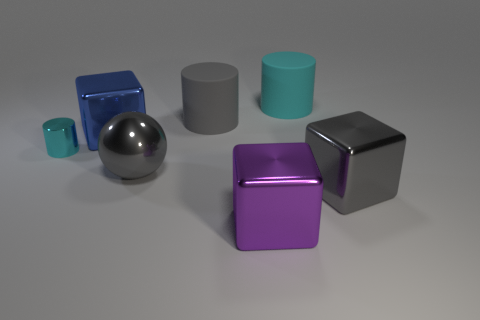There is a big gray cylinder; are there any big rubber things to the right of it?
Keep it short and to the point. Yes. What is the size of the metal block that is the same color as the large ball?
Offer a very short reply. Large. Is there a big purple thing that has the same material as the big ball?
Provide a short and direct response. Yes. The tiny metallic cylinder has what color?
Provide a succinct answer. Cyan. Is the shape of the large gray metallic object left of the gray cube the same as  the blue object?
Provide a succinct answer. No. The large gray thing behind the big gray metal object that is on the left side of the cylinder on the right side of the big purple block is what shape?
Your response must be concise. Cylinder. There is a cyan thing that is in front of the gray rubber cylinder; what is its material?
Provide a short and direct response. Metal. What color is the other cylinder that is the same size as the gray rubber cylinder?
Your answer should be compact. Cyan. How many other things are there of the same shape as the gray rubber thing?
Offer a terse response. 2. Does the gray metal sphere have the same size as the gray shiny block?
Offer a terse response. Yes. 